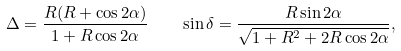<formula> <loc_0><loc_0><loc_500><loc_500>\Delta = \frac { R ( R + \cos 2 \alpha ) } { 1 + R \cos 2 \alpha } \quad \sin \delta = \frac { R \sin 2 \alpha } { \sqrt { 1 + R ^ { 2 } + 2 R \cos 2 \alpha } } ,</formula> 